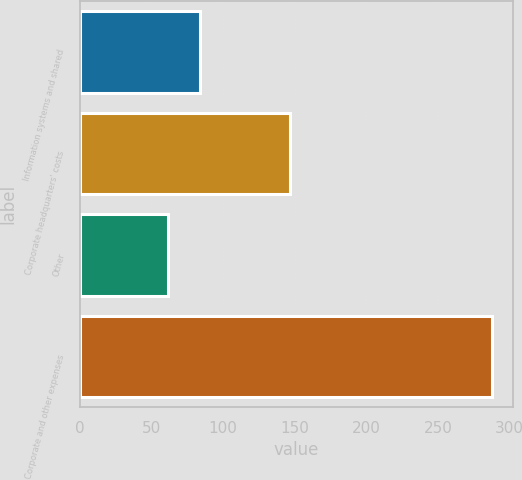Convert chart to OTSL. <chart><loc_0><loc_0><loc_500><loc_500><bar_chart><fcel>Information systems and shared<fcel>Corporate headquarters' costs<fcel>Other<fcel>Corporate and other expenses<nl><fcel>83.96<fcel>146.9<fcel>61.3<fcel>287.9<nl></chart> 